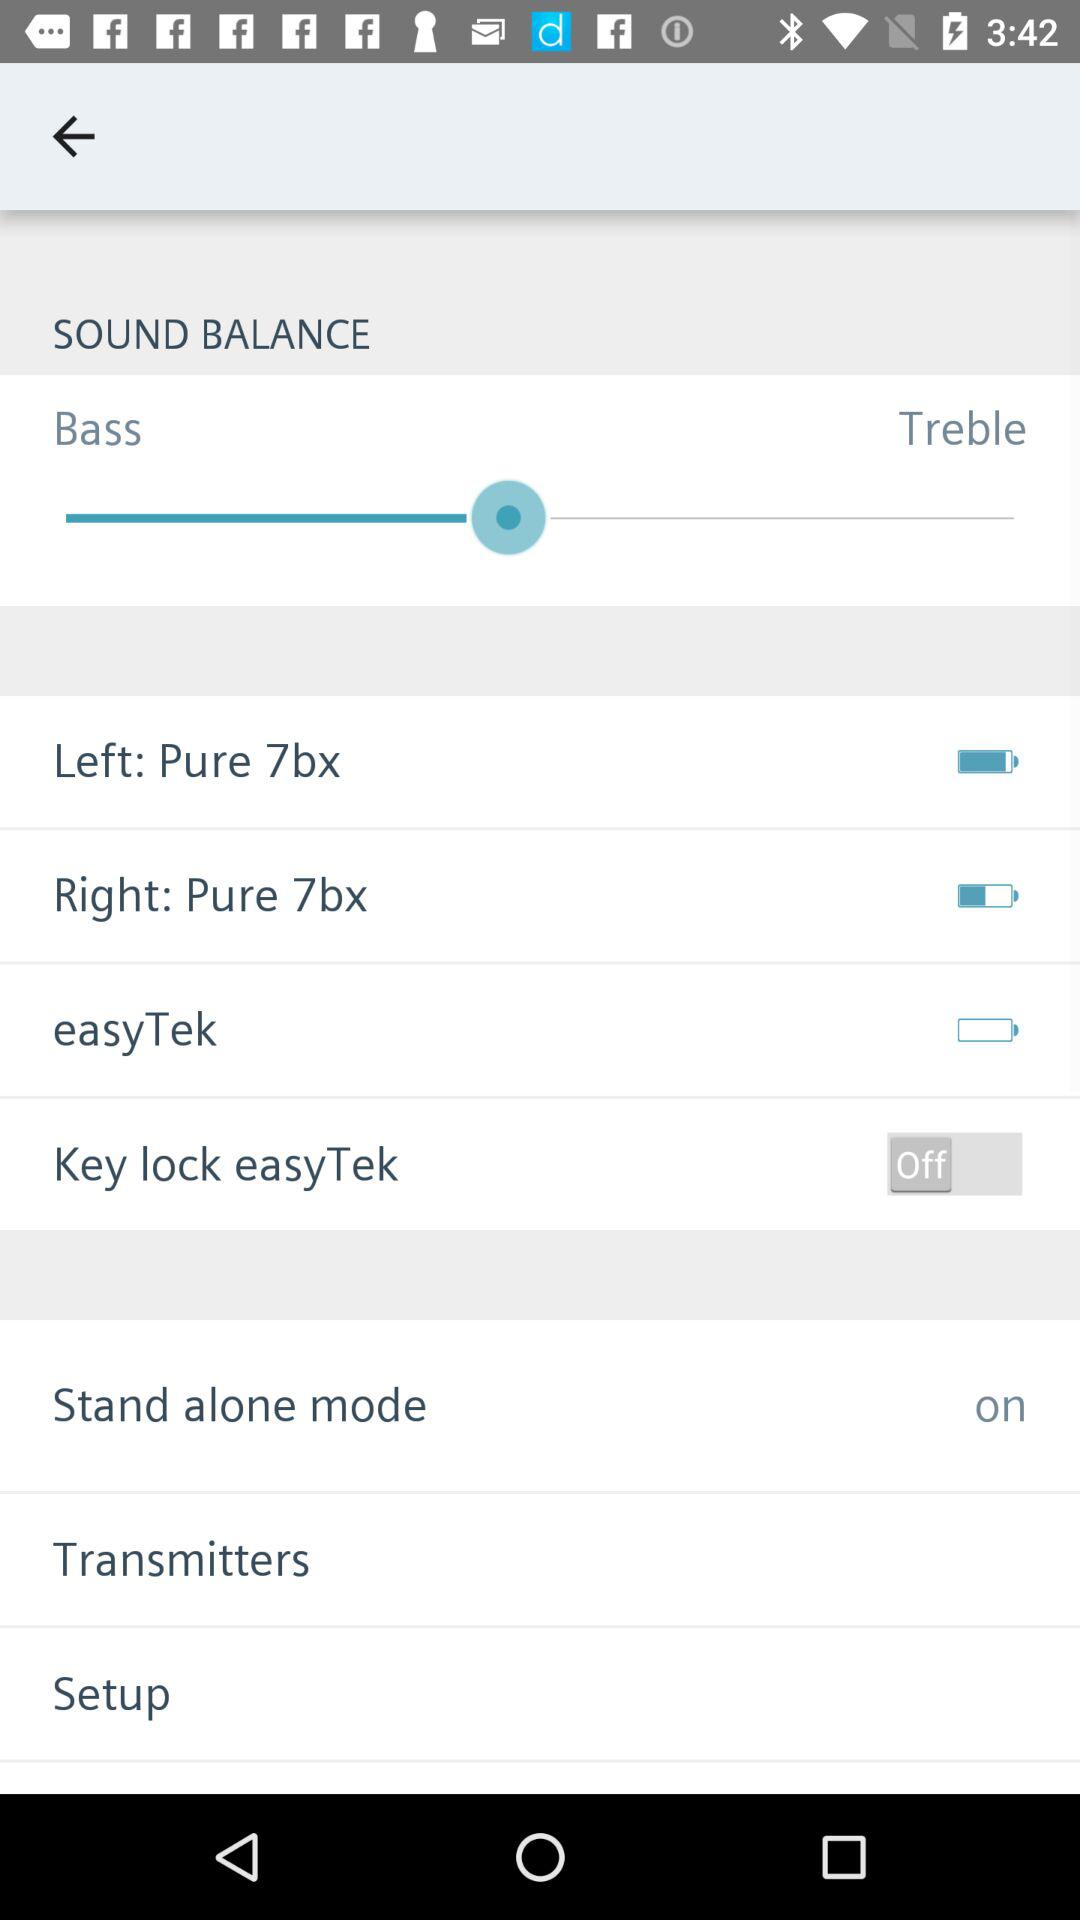What is the setting for the left? The setting for the "Left" is "Pure 7bx". 